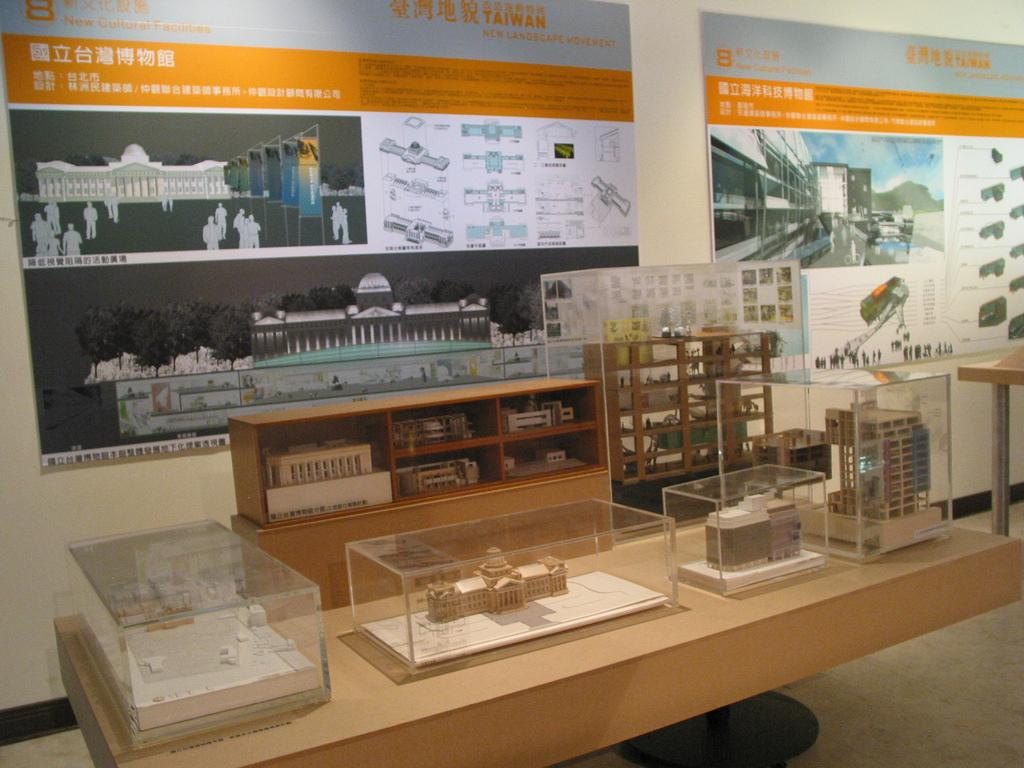What type of furniture is visible in the image? There are tables in the image. What is placed on the tables? Objects are placed in glass boxes on the tables. What can be seen in the background of the image? There are cupboards and banners in the background of the image. What type of hole can be seen in the image? There is no hole present in the image. What emotion might the objects in the glass boxes be feeling due to their placement? The objects in the glass boxes are inanimate and do not have emotions, so it is not possible to determine how they might feel. 